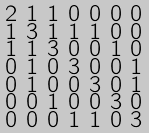<formula> <loc_0><loc_0><loc_500><loc_500>\begin{smallmatrix} 2 & 1 & 1 & 0 & 0 & 0 & 0 \\ 1 & 3 & 1 & 1 & 1 & 0 & 0 \\ 1 & 1 & 3 & 0 & 0 & 1 & 0 \\ 0 & 1 & 0 & 3 & 0 & 0 & 1 \\ 0 & 1 & 0 & 0 & 3 & 0 & 1 \\ 0 & 0 & 1 & 0 & 0 & 3 & 0 \\ 0 & 0 & 0 & 1 & 1 & 0 & 3 \end{smallmatrix}</formula> 